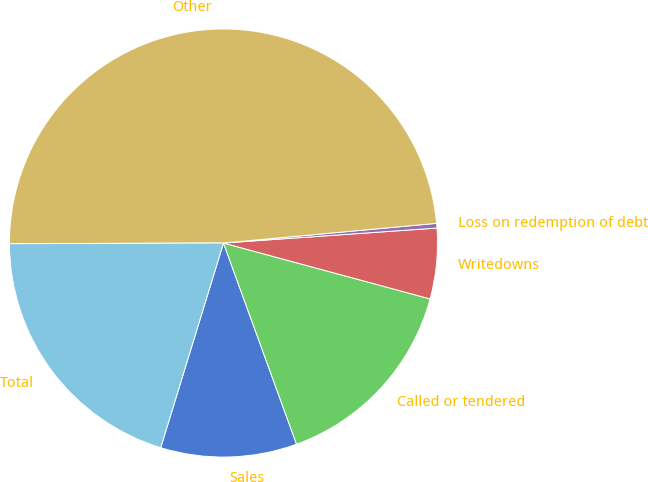Convert chart. <chart><loc_0><loc_0><loc_500><loc_500><pie_chart><fcel>Sales<fcel>Called or tendered<fcel>Writedowns<fcel>Loss on redemption of debt<fcel>Other<fcel>Total<nl><fcel>10.28%<fcel>15.25%<fcel>5.32%<fcel>0.35%<fcel>48.58%<fcel>20.21%<nl></chart> 